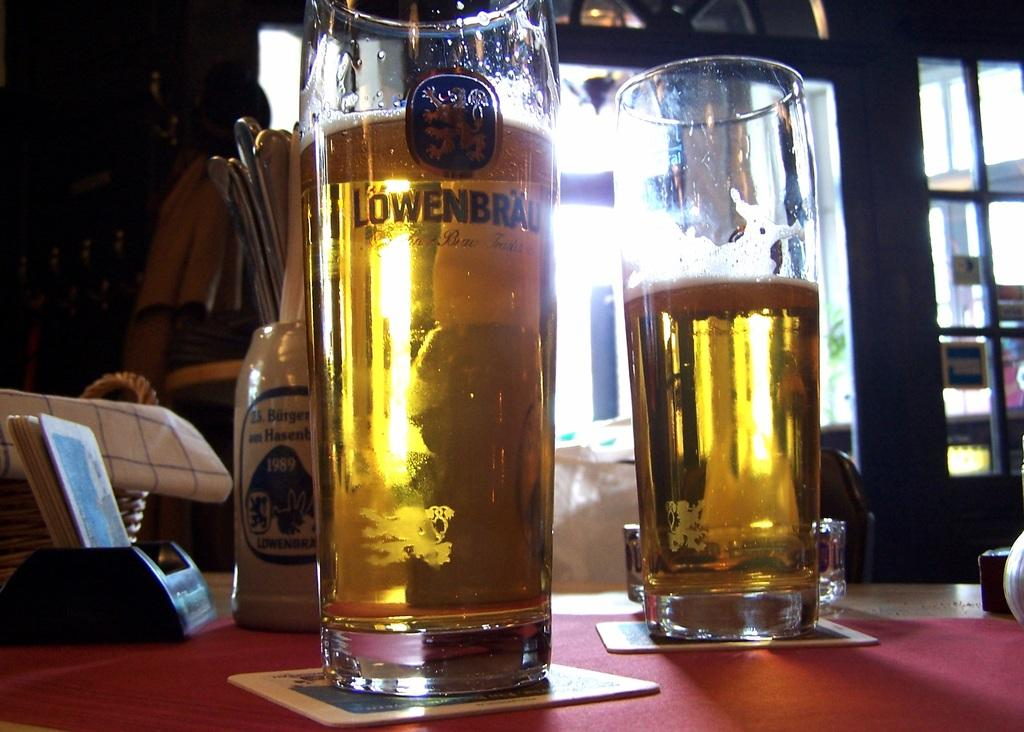<image>
Present a compact description of the photo's key features. a glass of alcohol with the word 'lowenbrall' labeled on it 